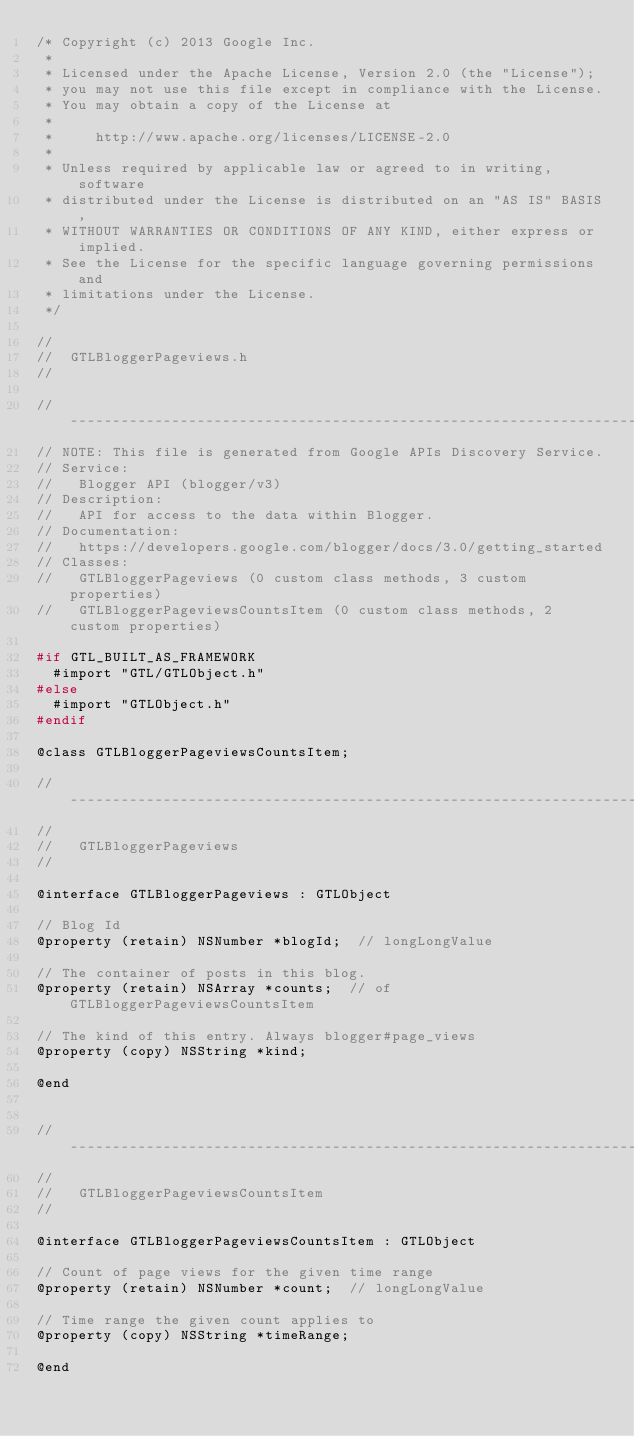<code> <loc_0><loc_0><loc_500><loc_500><_C_>/* Copyright (c) 2013 Google Inc.
 *
 * Licensed under the Apache License, Version 2.0 (the "License");
 * you may not use this file except in compliance with the License.
 * You may obtain a copy of the License at
 *
 *     http://www.apache.org/licenses/LICENSE-2.0
 *
 * Unless required by applicable law or agreed to in writing, software
 * distributed under the License is distributed on an "AS IS" BASIS,
 * WITHOUT WARRANTIES OR CONDITIONS OF ANY KIND, either express or implied.
 * See the License for the specific language governing permissions and
 * limitations under the License.
 */

//
//  GTLBloggerPageviews.h
//

// ----------------------------------------------------------------------------
// NOTE: This file is generated from Google APIs Discovery Service.
// Service:
//   Blogger API (blogger/v3)
// Description:
//   API for access to the data within Blogger.
// Documentation:
//   https://developers.google.com/blogger/docs/3.0/getting_started
// Classes:
//   GTLBloggerPageviews (0 custom class methods, 3 custom properties)
//   GTLBloggerPageviewsCountsItem (0 custom class methods, 2 custom properties)

#if GTL_BUILT_AS_FRAMEWORK
  #import "GTL/GTLObject.h"
#else
  #import "GTLObject.h"
#endif

@class GTLBloggerPageviewsCountsItem;

// ----------------------------------------------------------------------------
//
//   GTLBloggerPageviews
//

@interface GTLBloggerPageviews : GTLObject

// Blog Id
@property (retain) NSNumber *blogId;  // longLongValue

// The container of posts in this blog.
@property (retain) NSArray *counts;  // of GTLBloggerPageviewsCountsItem

// The kind of this entry. Always blogger#page_views
@property (copy) NSString *kind;

@end


// ----------------------------------------------------------------------------
//
//   GTLBloggerPageviewsCountsItem
//

@interface GTLBloggerPageviewsCountsItem : GTLObject

// Count of page views for the given time range
@property (retain) NSNumber *count;  // longLongValue

// Time range the given count applies to
@property (copy) NSString *timeRange;

@end
</code> 